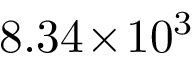Convert formula to latex. <formula><loc_0><loc_0><loc_500><loc_500>8 . 3 4 \, \times \, 1 0 ^ { 3 }</formula> 